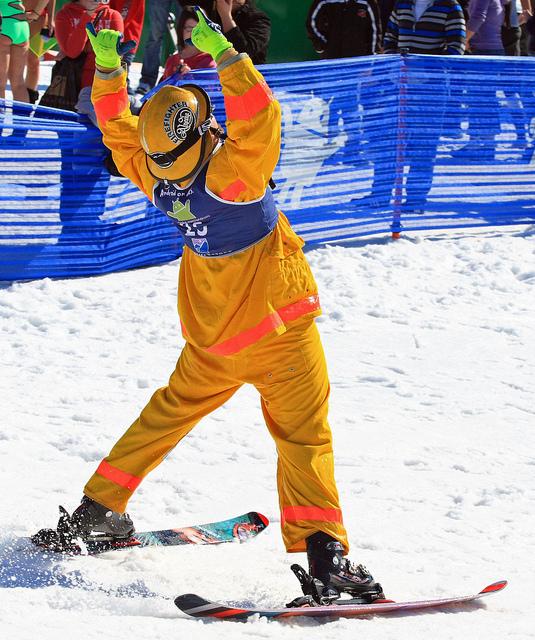Is the kid wearing both skis?
Concise answer only. Yes. What color shirt is the guy wearing?
Be succinct. Yellow. Why might this be a competition?
Give a very brief answer. Vest. What is this guy doing?
Answer briefly. Skiing. 